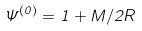Convert formula to latex. <formula><loc_0><loc_0><loc_500><loc_500>\Psi ^ { ( 0 ) } = 1 + M / 2 R</formula> 